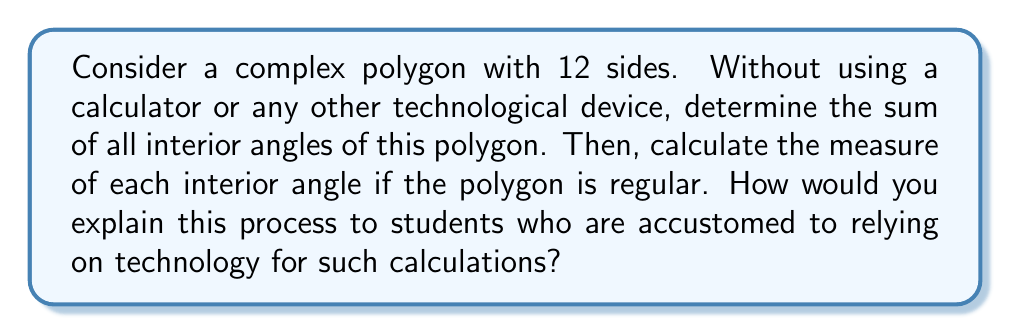Show me your answer to this math problem. 1. Recall the formula for the sum of interior angles of a polygon:
   $$S = (n - 2) \times 180°$$
   where $n$ is the number of sides.

2. For a 12-sided polygon (dodecagon), $n = 12$:
   $$S = (12 - 2) \times 180° = 10 \times 180° = 1800°$$

3. To find each interior angle of a regular dodecagon:
   - In a regular polygon, all interior angles are equal.
   - Divide the sum by the number of angles:
     $$\text{Each angle} = \frac{1800°}{12} = 150°$$

4. Mental calculation trick:
   - $1800 \div 12 = (1800 \div 2) \div 6 = 900 \div 6 = 150$

5. To explain to students without technology:
   - Use the formula and break down calculations into simpler steps.
   - Encourage mental math strategies, like dividing by 2 then by 6.
   - Draw the polygon and visually demonstrate angle relationships.
   - Relate to simpler polygons they know (e.g., hexagon has 720°, so dodecagon has 2.5 times that).
Answer: Sum of interior angles: 1800°; Each interior angle (if regular): 150° 